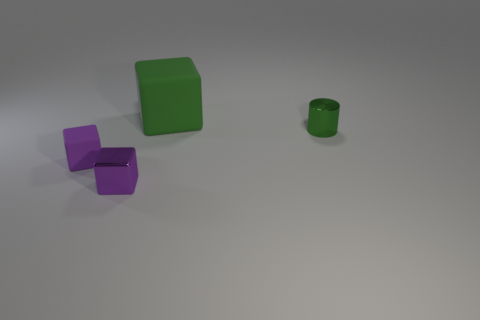What is the color of the matte block in front of the rubber thing behind the tiny green object? The matte block situated in front of the rubber object, which is behind the tiny green object, is purple in color, appearing with a non-reflective finish that distinguishes its texture from the surrounding items. 